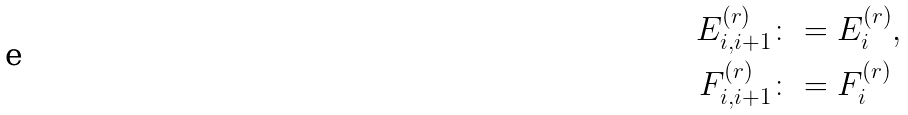Convert formula to latex. <formula><loc_0><loc_0><loc_500><loc_500>E _ { i , i + 1 } ^ { ( r ) } & \colon = E _ { i } ^ { ( r ) } , \\ F _ { i , i + 1 } ^ { ( r ) } & \colon = F _ { i } ^ { ( r ) }</formula> 